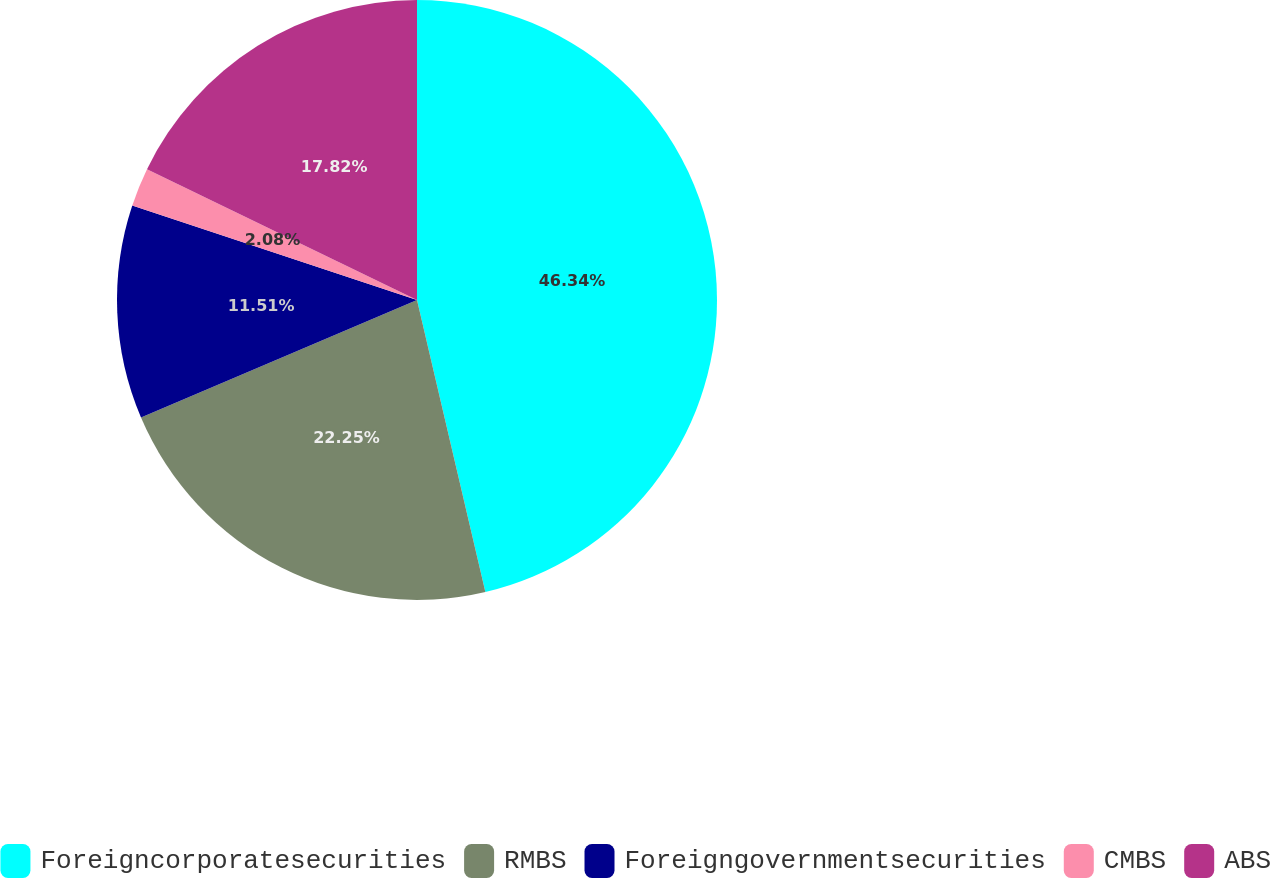Convert chart to OTSL. <chart><loc_0><loc_0><loc_500><loc_500><pie_chart><fcel>Foreigncorporatesecurities<fcel>RMBS<fcel>Foreigngovernmentsecurities<fcel>CMBS<fcel>ABS<nl><fcel>46.34%<fcel>22.25%<fcel>11.51%<fcel>2.08%<fcel>17.82%<nl></chart> 